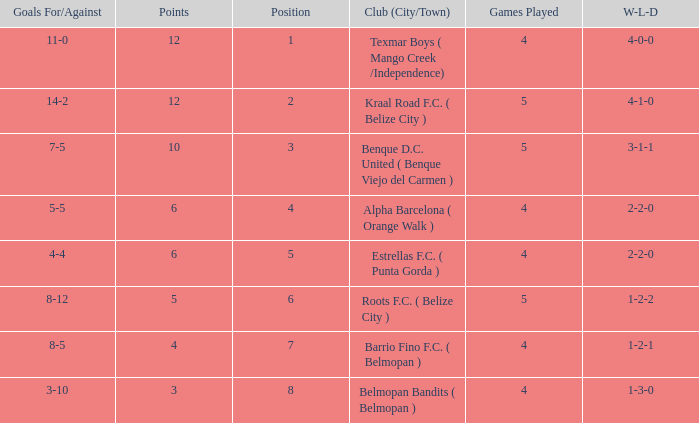What's the goals for/against with w-l-d being 3-1-1 7-5. 